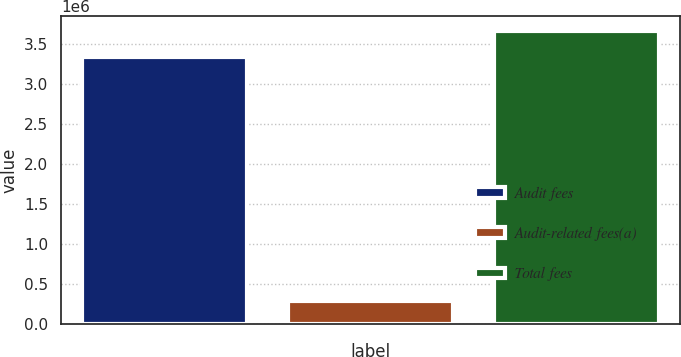<chart> <loc_0><loc_0><loc_500><loc_500><bar_chart><fcel>Audit fees<fcel>Audit-related fees(a)<fcel>Total fees<nl><fcel>3.32969e+06<fcel>281748<fcel>3.66266e+06<nl></chart> 